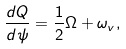<formula> <loc_0><loc_0><loc_500><loc_500>\frac { d Q } { d \psi } = \frac { 1 } { 2 } \Omega + \omega _ { v } ,</formula> 